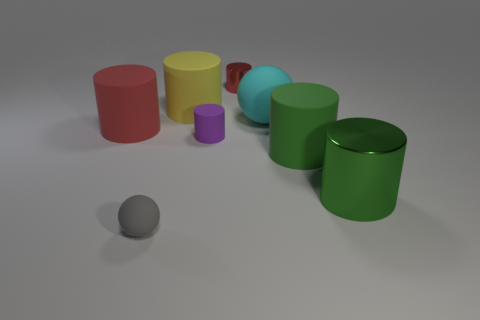Subtract 2 cylinders. How many cylinders are left? 4 Subtract all purple cylinders. How many cylinders are left? 5 Subtract all red cylinders. How many cylinders are left? 4 Subtract all red cylinders. Subtract all yellow balls. How many cylinders are left? 4 Add 1 big matte things. How many objects exist? 9 Subtract all cylinders. How many objects are left? 2 Add 1 large yellow cylinders. How many large yellow cylinders exist? 2 Subtract 0 brown spheres. How many objects are left? 8 Subtract all tiny yellow blocks. Subtract all large yellow cylinders. How many objects are left? 7 Add 5 yellow cylinders. How many yellow cylinders are left? 6 